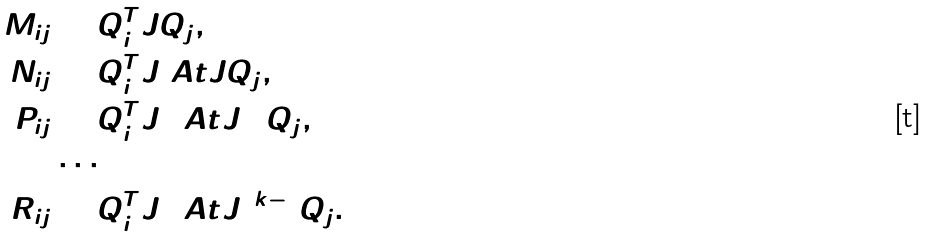Convert formula to latex. <formula><loc_0><loc_0><loc_500><loc_500>M _ { i j } & = Q _ { i } ^ { T } J Q _ { j } , \\ N _ { i j } & = Q _ { i } ^ { T } J \ A t J Q _ { j } , \\ P _ { i j } & = Q _ { i } ^ { T } J ( \ A t J ) ^ { 2 } Q _ { j } , \\ & \cdots \\ R _ { i j } & = Q _ { i } ^ { T } J ( \ A t J ) ^ { k - 1 } Q _ { j } .</formula> 